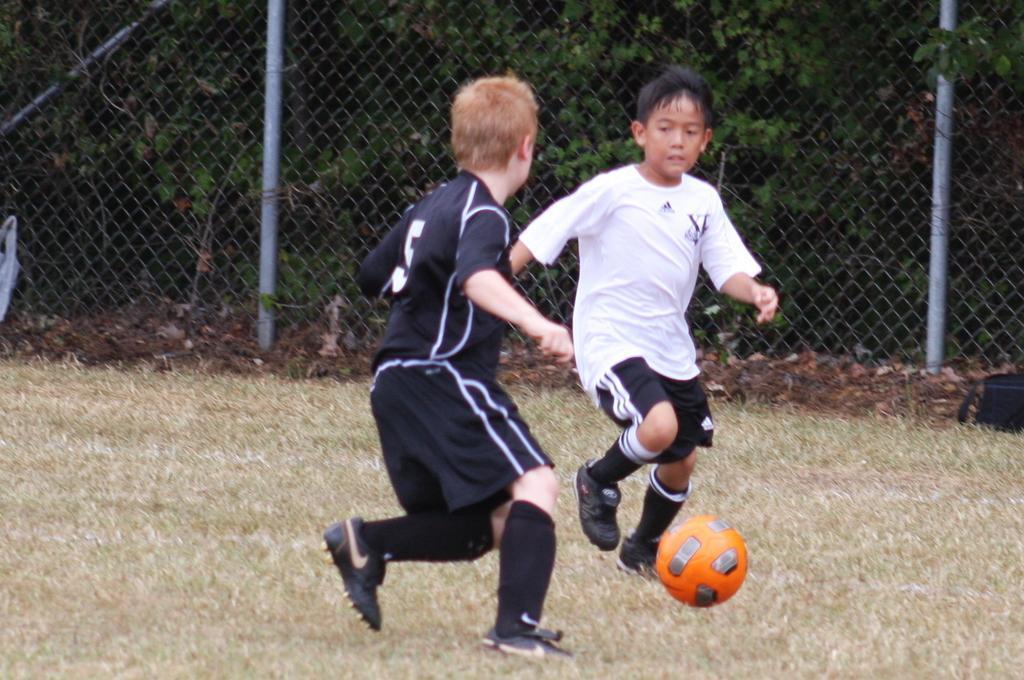Can you describe this image briefly? In this image two children are playing football on the surface of the grass. At the back side there is a closed mesh fencing. 